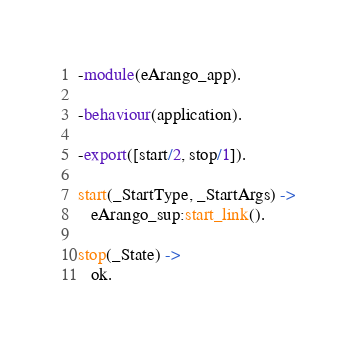Convert code to text. <code><loc_0><loc_0><loc_500><loc_500><_Erlang_>-module(eArango_app).

-behaviour(application).

-export([start/2, stop/1]).

start(_StartType, _StartArgs) ->
   eArango_sup:start_link().

stop(_State) ->
   ok.
</code> 